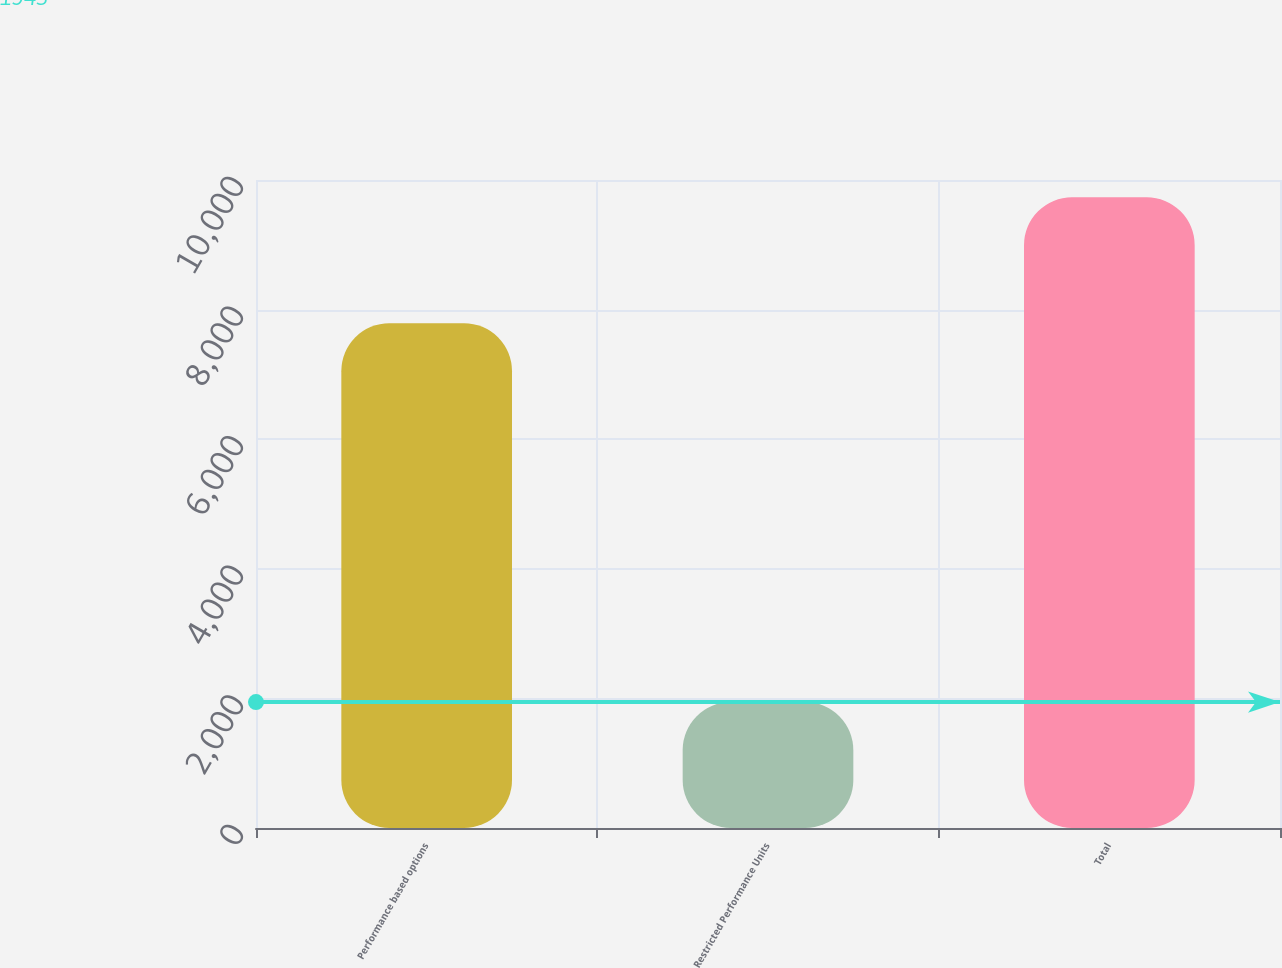<chart> <loc_0><loc_0><loc_500><loc_500><bar_chart><fcel>Performance based options<fcel>Restricted Performance Units<fcel>Total<nl><fcel>7791<fcel>1943<fcel>9734<nl></chart> 